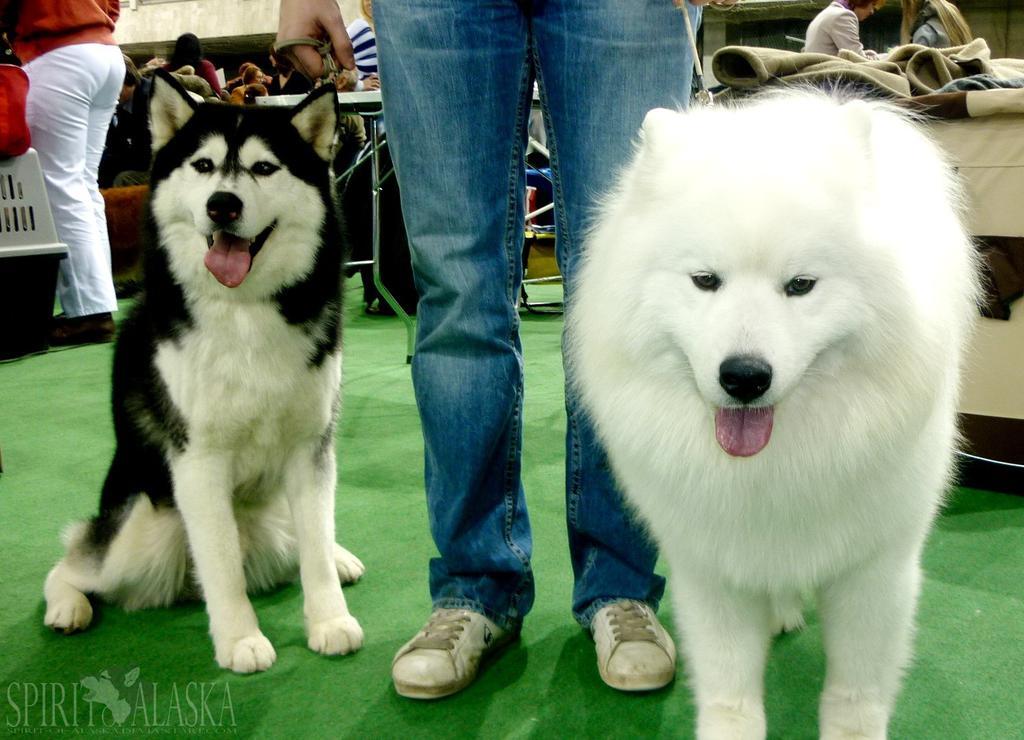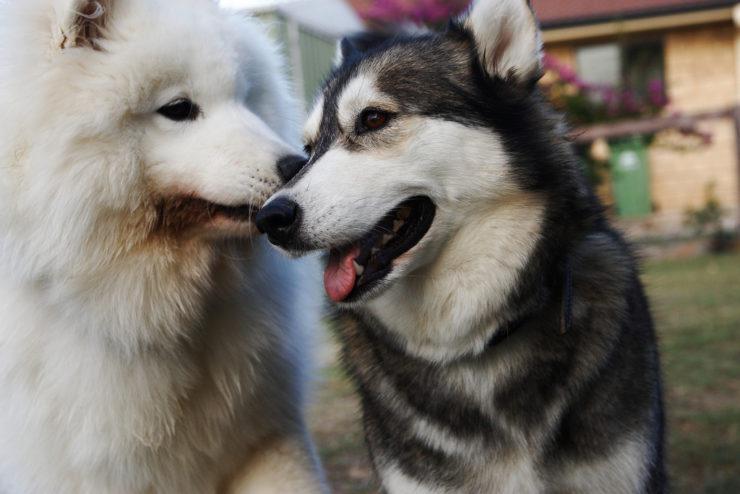The first image is the image on the left, the second image is the image on the right. Assess this claim about the two images: "In one of the images there is a small black dog on top of a big white dog that is laying on the floor.". Correct or not? Answer yes or no. No. The first image is the image on the left, the second image is the image on the right. Given the left and right images, does the statement "A person wearing jeans is next to multiple dogs in one image." hold true? Answer yes or no. Yes. 